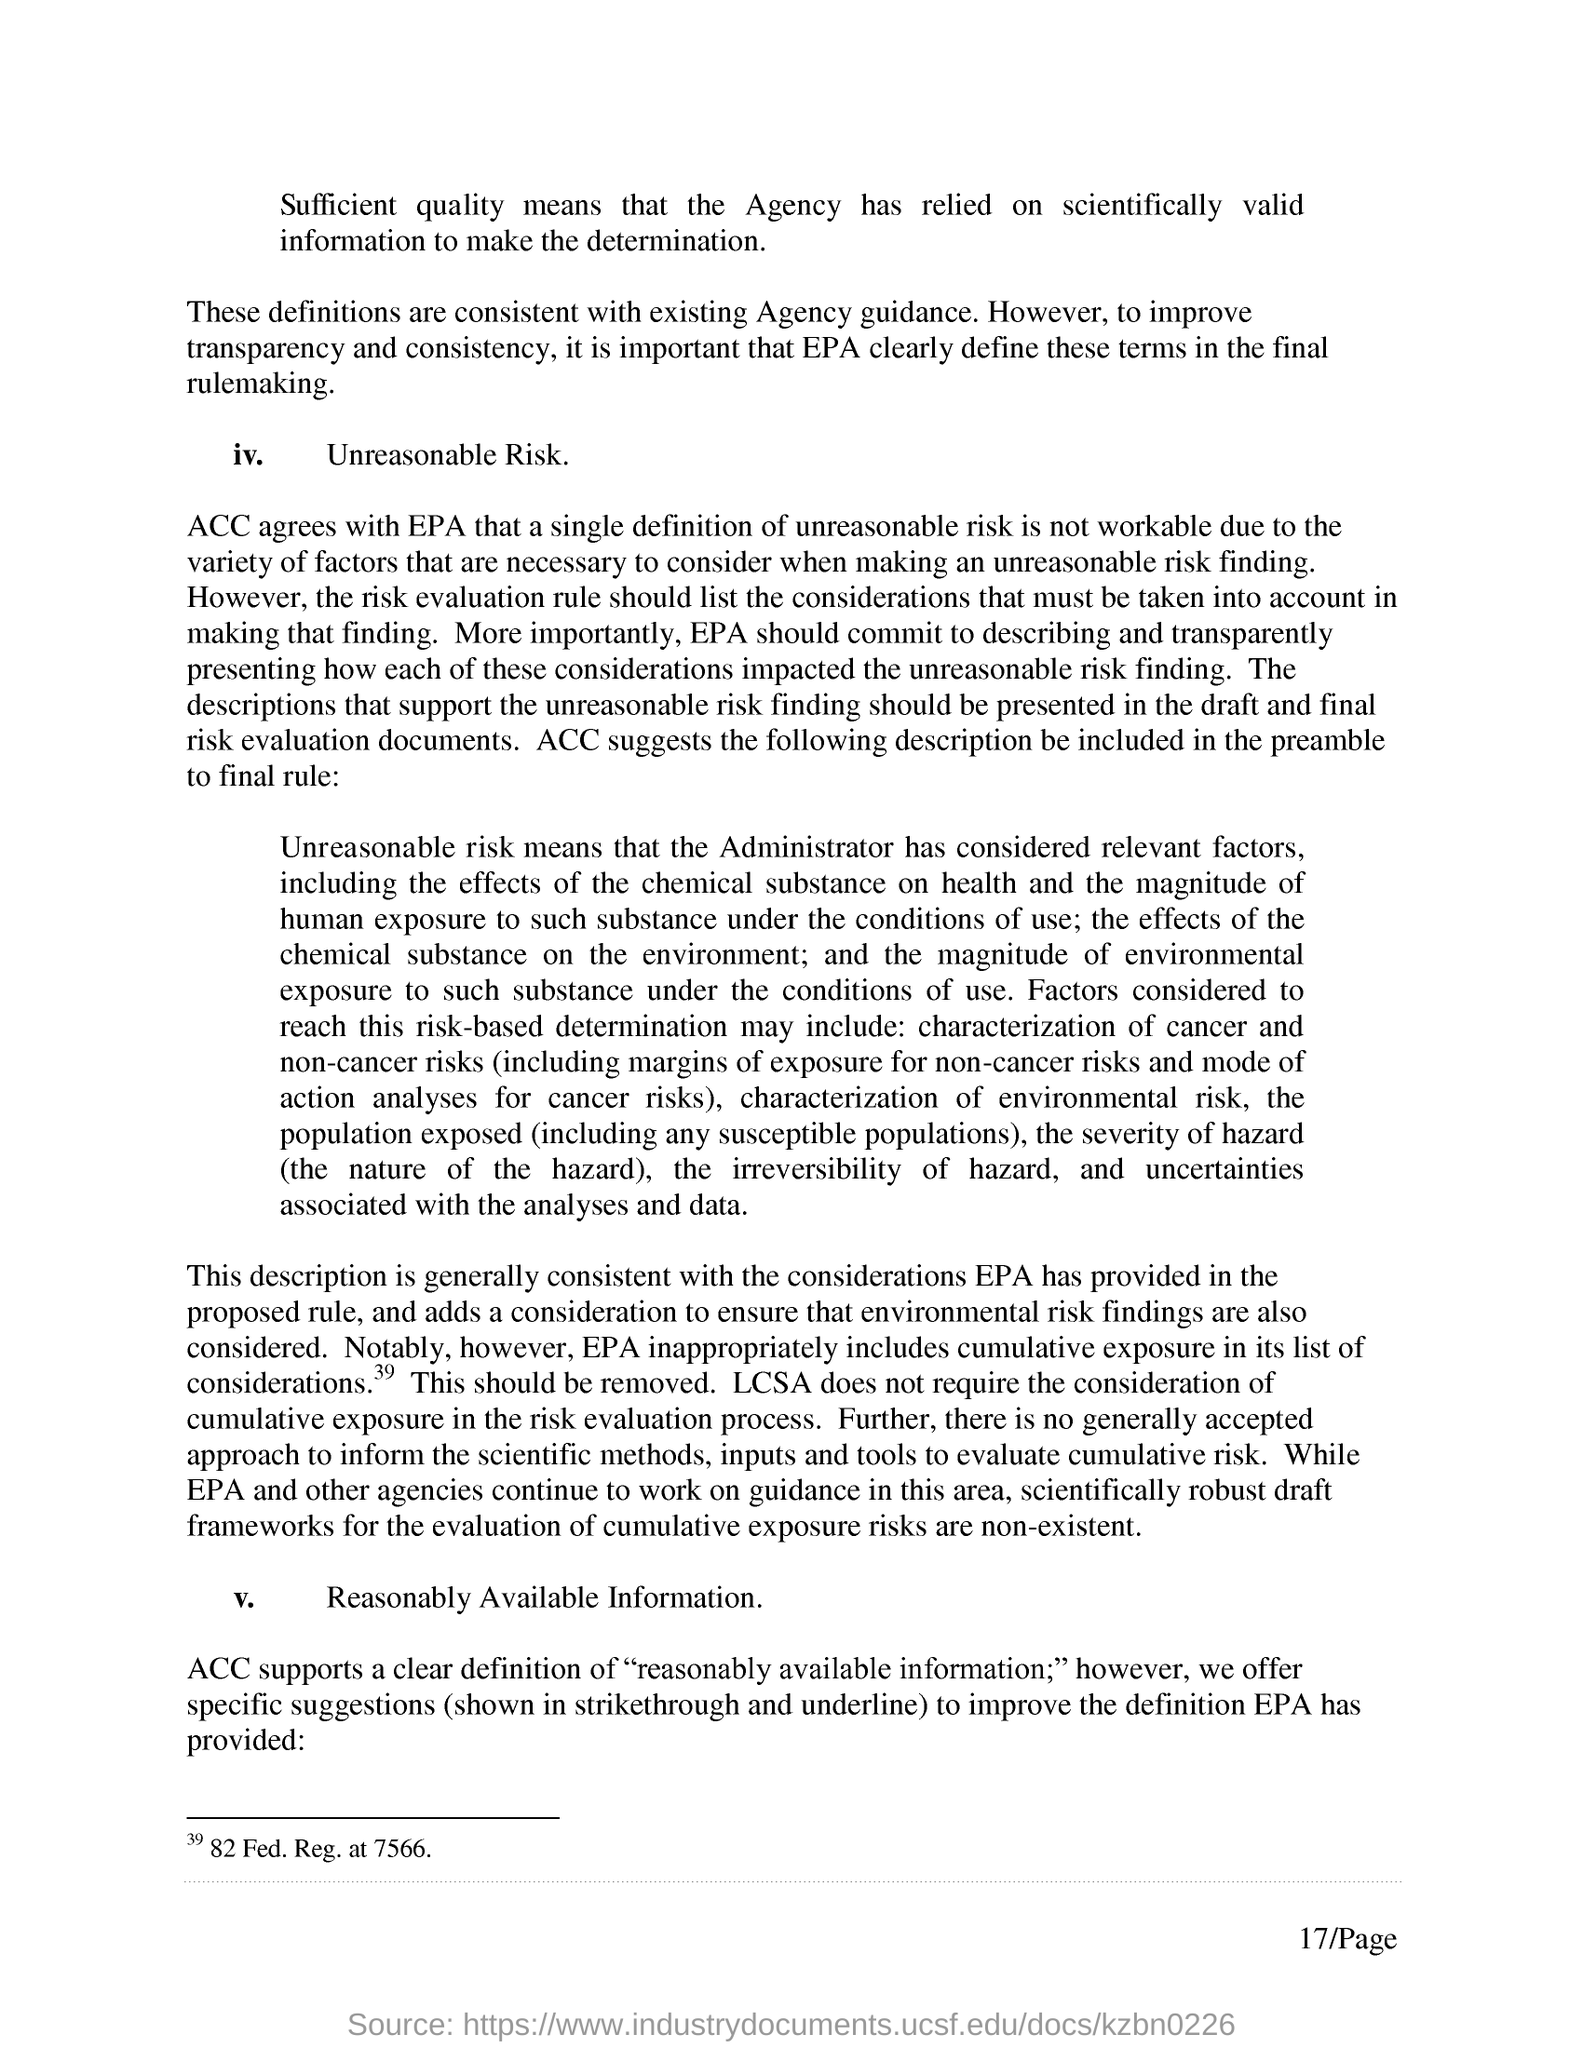What does ACC supports?
Provide a succinct answer. A CLEAR DEFINITION OF "REASONABLY AVAILABLE INFORMATION;". What is the page no mentioned in this document?
Give a very brief answer. 17/Page. 